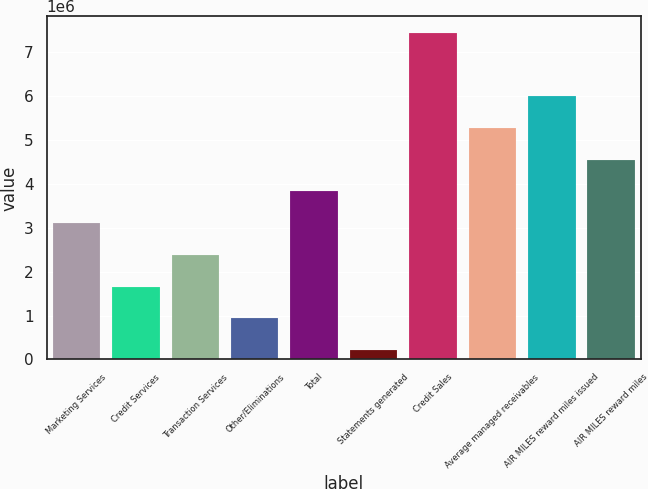<chart> <loc_0><loc_0><loc_500><loc_500><bar_chart><fcel>Marketing Services<fcel>Credit Services<fcel>Transaction Services<fcel>Other/Eliminations<fcel>Total<fcel>Statements generated<fcel>Credit Sales<fcel>Average managed receivables<fcel>AIR MILES reward miles issued<fcel>AIR MILES reward miles<nl><fcel>3.10472e+06<fcel>1.65819e+06<fcel>2.38145e+06<fcel>934926<fcel>3.82798e+06<fcel>211663<fcel>7.4443e+06<fcel>5.27451e+06<fcel>5.99777e+06<fcel>4.55124e+06<nl></chart> 